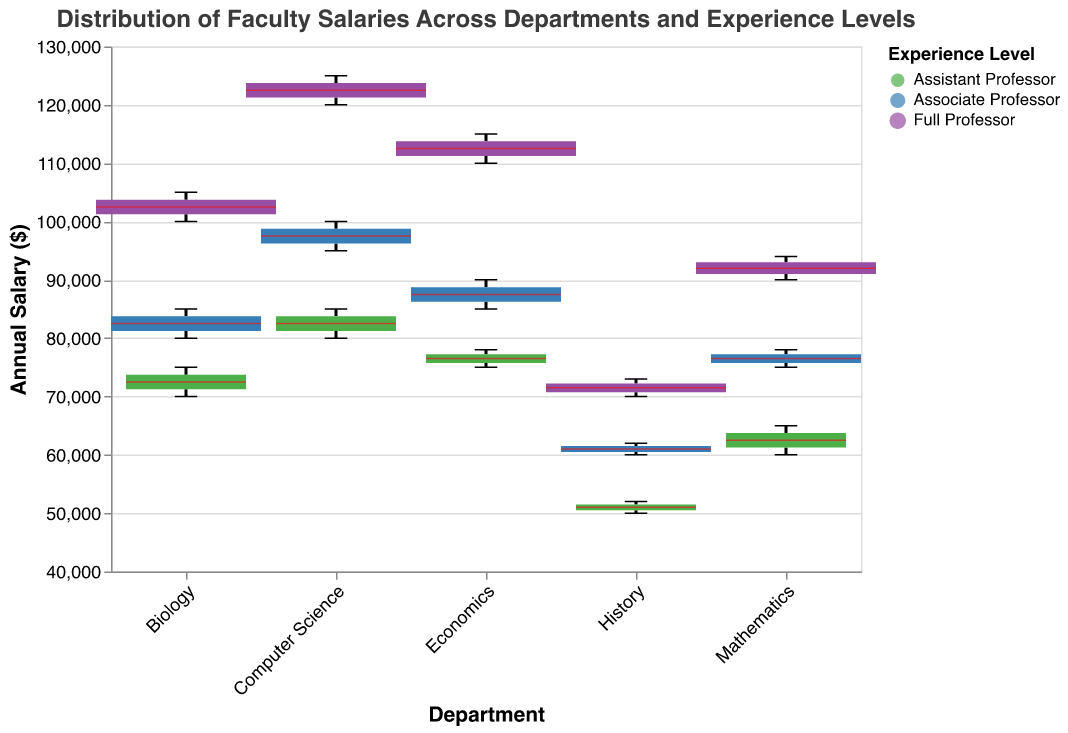Which department has the widest range in salaries for Full Professors? By looking at the boxplots and the horizontal extent of each box, the one with the greatest width for Full Professors is for the Computer Science department.
Answer: Computer Science Which department has the highest median salary for Associate Professors? One can look at the position of the median line within the boxplots that represent Associate Professors. The Economics department shows the highest median salary here.
Answer: Economics What is the approximate salary range for Assistant Professors in the Mathematics department? By focusing on the boxplot for Assistant Professors in the Mathematics department, we can see the range extends from approximately $60,000 to $65,000.
Answer: $60,000 - $65,000 Compare the median salaries of Full Professors in Biology and Economics. Which one is higher? To determine this, look at the median lines within the Full Professor boxplots for each department. The Economics median line is higher than Biology’s.
Answer: Economics What is the minimum salary observed for the Assistant Professors in the History department? By looking at the bottom whisker (the lowest point) of the History Assistant Professor boxplot, the minimum salary is approximately $50,000.
Answer: $50,000 Which department shows the smallest difference in salary ranges between Associate Professors and Full Professors? By comparing the height of the boxes and whiskers for Associate and Full Professors across departments, the Mathematics department shows the smallest range difference.
Answer: Mathematics How does the width of boxplots vary with experience levels and why? The widths of the boxplots vary based on the number of data points in each experience level, with Full Professors having the widest boxplots because their corresponding filled circle size (160) is the largest.
Answer: Correlated with number of data points and size encoding 